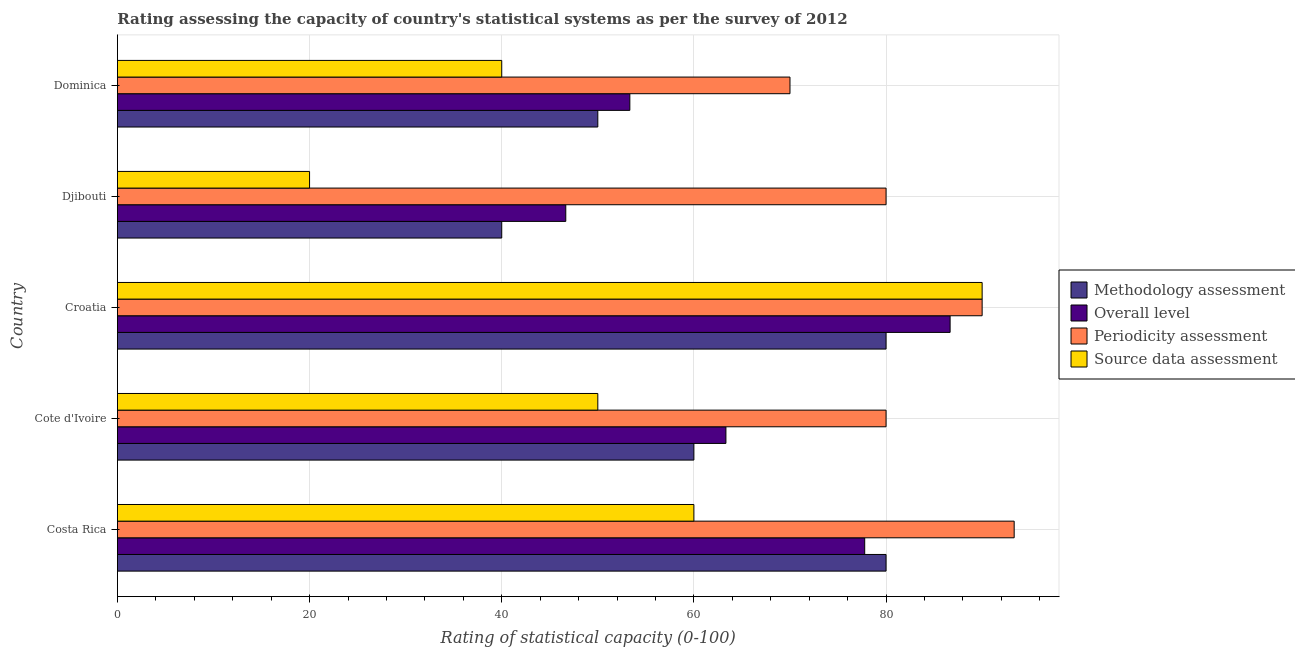How many groups of bars are there?
Your answer should be very brief. 5. Are the number of bars on each tick of the Y-axis equal?
Provide a short and direct response. Yes. What is the label of the 3rd group of bars from the top?
Give a very brief answer. Croatia. In how many cases, is the number of bars for a given country not equal to the number of legend labels?
Make the answer very short. 0. What is the periodicity assessment rating in Djibouti?
Ensure brevity in your answer.  80. Across all countries, what is the maximum source data assessment rating?
Give a very brief answer. 90. In which country was the source data assessment rating maximum?
Offer a terse response. Croatia. In which country was the source data assessment rating minimum?
Provide a short and direct response. Djibouti. What is the total source data assessment rating in the graph?
Keep it short and to the point. 260. What is the difference between the methodology assessment rating in Djibouti and that in Dominica?
Provide a short and direct response. -10. What is the difference between the source data assessment rating in Costa Rica and the overall level rating in Croatia?
Your response must be concise. -26.67. Is the overall level rating in Cote d'Ivoire less than that in Dominica?
Your answer should be very brief. No. What is the difference between the highest and the second highest periodicity assessment rating?
Offer a very short reply. 3.33. In how many countries, is the methodology assessment rating greater than the average methodology assessment rating taken over all countries?
Ensure brevity in your answer.  2. What does the 2nd bar from the top in Cote d'Ivoire represents?
Make the answer very short. Periodicity assessment. What does the 3rd bar from the bottom in Djibouti represents?
Your answer should be compact. Periodicity assessment. Are all the bars in the graph horizontal?
Your answer should be very brief. Yes. What is the difference between two consecutive major ticks on the X-axis?
Your response must be concise. 20. Does the graph contain any zero values?
Provide a succinct answer. No. How are the legend labels stacked?
Your answer should be compact. Vertical. What is the title of the graph?
Provide a succinct answer. Rating assessing the capacity of country's statistical systems as per the survey of 2012 . What is the label or title of the X-axis?
Provide a succinct answer. Rating of statistical capacity (0-100). What is the label or title of the Y-axis?
Offer a very short reply. Country. What is the Rating of statistical capacity (0-100) of Overall level in Costa Rica?
Provide a succinct answer. 77.78. What is the Rating of statistical capacity (0-100) in Periodicity assessment in Costa Rica?
Keep it short and to the point. 93.33. What is the Rating of statistical capacity (0-100) of Methodology assessment in Cote d'Ivoire?
Offer a very short reply. 60. What is the Rating of statistical capacity (0-100) of Overall level in Cote d'Ivoire?
Provide a succinct answer. 63.33. What is the Rating of statistical capacity (0-100) in Periodicity assessment in Cote d'Ivoire?
Offer a very short reply. 80. What is the Rating of statistical capacity (0-100) of Source data assessment in Cote d'Ivoire?
Provide a short and direct response. 50. What is the Rating of statistical capacity (0-100) in Methodology assessment in Croatia?
Provide a short and direct response. 80. What is the Rating of statistical capacity (0-100) in Overall level in Croatia?
Your response must be concise. 86.67. What is the Rating of statistical capacity (0-100) of Overall level in Djibouti?
Your response must be concise. 46.67. What is the Rating of statistical capacity (0-100) of Periodicity assessment in Djibouti?
Ensure brevity in your answer.  80. What is the Rating of statistical capacity (0-100) of Overall level in Dominica?
Provide a succinct answer. 53.33. What is the Rating of statistical capacity (0-100) of Periodicity assessment in Dominica?
Ensure brevity in your answer.  70. Across all countries, what is the maximum Rating of statistical capacity (0-100) in Overall level?
Give a very brief answer. 86.67. Across all countries, what is the maximum Rating of statistical capacity (0-100) in Periodicity assessment?
Give a very brief answer. 93.33. Across all countries, what is the maximum Rating of statistical capacity (0-100) in Source data assessment?
Offer a terse response. 90. Across all countries, what is the minimum Rating of statistical capacity (0-100) in Methodology assessment?
Keep it short and to the point. 40. Across all countries, what is the minimum Rating of statistical capacity (0-100) in Overall level?
Keep it short and to the point. 46.67. Across all countries, what is the minimum Rating of statistical capacity (0-100) in Periodicity assessment?
Keep it short and to the point. 70. Across all countries, what is the minimum Rating of statistical capacity (0-100) in Source data assessment?
Your response must be concise. 20. What is the total Rating of statistical capacity (0-100) in Methodology assessment in the graph?
Provide a short and direct response. 310. What is the total Rating of statistical capacity (0-100) of Overall level in the graph?
Your response must be concise. 327.78. What is the total Rating of statistical capacity (0-100) of Periodicity assessment in the graph?
Ensure brevity in your answer.  413.33. What is the total Rating of statistical capacity (0-100) of Source data assessment in the graph?
Provide a short and direct response. 260. What is the difference between the Rating of statistical capacity (0-100) in Overall level in Costa Rica and that in Cote d'Ivoire?
Keep it short and to the point. 14.44. What is the difference between the Rating of statistical capacity (0-100) in Periodicity assessment in Costa Rica and that in Cote d'Ivoire?
Offer a very short reply. 13.33. What is the difference between the Rating of statistical capacity (0-100) of Source data assessment in Costa Rica and that in Cote d'Ivoire?
Your answer should be very brief. 10. What is the difference between the Rating of statistical capacity (0-100) in Overall level in Costa Rica and that in Croatia?
Keep it short and to the point. -8.89. What is the difference between the Rating of statistical capacity (0-100) of Source data assessment in Costa Rica and that in Croatia?
Ensure brevity in your answer.  -30. What is the difference between the Rating of statistical capacity (0-100) of Overall level in Costa Rica and that in Djibouti?
Provide a succinct answer. 31.11. What is the difference between the Rating of statistical capacity (0-100) in Periodicity assessment in Costa Rica and that in Djibouti?
Provide a short and direct response. 13.33. What is the difference between the Rating of statistical capacity (0-100) in Source data assessment in Costa Rica and that in Djibouti?
Make the answer very short. 40. What is the difference between the Rating of statistical capacity (0-100) of Methodology assessment in Costa Rica and that in Dominica?
Keep it short and to the point. 30. What is the difference between the Rating of statistical capacity (0-100) in Overall level in Costa Rica and that in Dominica?
Make the answer very short. 24.44. What is the difference between the Rating of statistical capacity (0-100) of Periodicity assessment in Costa Rica and that in Dominica?
Keep it short and to the point. 23.33. What is the difference between the Rating of statistical capacity (0-100) in Methodology assessment in Cote d'Ivoire and that in Croatia?
Offer a very short reply. -20. What is the difference between the Rating of statistical capacity (0-100) in Overall level in Cote d'Ivoire and that in Croatia?
Make the answer very short. -23.33. What is the difference between the Rating of statistical capacity (0-100) of Periodicity assessment in Cote d'Ivoire and that in Croatia?
Provide a succinct answer. -10. What is the difference between the Rating of statistical capacity (0-100) of Source data assessment in Cote d'Ivoire and that in Croatia?
Make the answer very short. -40. What is the difference between the Rating of statistical capacity (0-100) of Overall level in Cote d'Ivoire and that in Djibouti?
Give a very brief answer. 16.67. What is the difference between the Rating of statistical capacity (0-100) in Periodicity assessment in Cote d'Ivoire and that in Djibouti?
Provide a succinct answer. 0. What is the difference between the Rating of statistical capacity (0-100) in Methodology assessment in Cote d'Ivoire and that in Dominica?
Offer a terse response. 10. What is the difference between the Rating of statistical capacity (0-100) in Periodicity assessment in Cote d'Ivoire and that in Dominica?
Offer a very short reply. 10. What is the difference between the Rating of statistical capacity (0-100) in Periodicity assessment in Croatia and that in Djibouti?
Keep it short and to the point. 10. What is the difference between the Rating of statistical capacity (0-100) of Source data assessment in Croatia and that in Djibouti?
Keep it short and to the point. 70. What is the difference between the Rating of statistical capacity (0-100) of Methodology assessment in Croatia and that in Dominica?
Ensure brevity in your answer.  30. What is the difference between the Rating of statistical capacity (0-100) of Overall level in Croatia and that in Dominica?
Offer a very short reply. 33.33. What is the difference between the Rating of statistical capacity (0-100) of Overall level in Djibouti and that in Dominica?
Offer a very short reply. -6.67. What is the difference between the Rating of statistical capacity (0-100) in Methodology assessment in Costa Rica and the Rating of statistical capacity (0-100) in Overall level in Cote d'Ivoire?
Make the answer very short. 16.67. What is the difference between the Rating of statistical capacity (0-100) in Methodology assessment in Costa Rica and the Rating of statistical capacity (0-100) in Periodicity assessment in Cote d'Ivoire?
Provide a short and direct response. 0. What is the difference between the Rating of statistical capacity (0-100) in Methodology assessment in Costa Rica and the Rating of statistical capacity (0-100) in Source data assessment in Cote d'Ivoire?
Your response must be concise. 30. What is the difference between the Rating of statistical capacity (0-100) in Overall level in Costa Rica and the Rating of statistical capacity (0-100) in Periodicity assessment in Cote d'Ivoire?
Give a very brief answer. -2.22. What is the difference between the Rating of statistical capacity (0-100) of Overall level in Costa Rica and the Rating of statistical capacity (0-100) of Source data assessment in Cote d'Ivoire?
Give a very brief answer. 27.78. What is the difference between the Rating of statistical capacity (0-100) in Periodicity assessment in Costa Rica and the Rating of statistical capacity (0-100) in Source data assessment in Cote d'Ivoire?
Offer a very short reply. 43.33. What is the difference between the Rating of statistical capacity (0-100) of Methodology assessment in Costa Rica and the Rating of statistical capacity (0-100) of Overall level in Croatia?
Ensure brevity in your answer.  -6.67. What is the difference between the Rating of statistical capacity (0-100) of Methodology assessment in Costa Rica and the Rating of statistical capacity (0-100) of Source data assessment in Croatia?
Your answer should be very brief. -10. What is the difference between the Rating of statistical capacity (0-100) of Overall level in Costa Rica and the Rating of statistical capacity (0-100) of Periodicity assessment in Croatia?
Offer a very short reply. -12.22. What is the difference between the Rating of statistical capacity (0-100) in Overall level in Costa Rica and the Rating of statistical capacity (0-100) in Source data assessment in Croatia?
Your answer should be very brief. -12.22. What is the difference between the Rating of statistical capacity (0-100) in Periodicity assessment in Costa Rica and the Rating of statistical capacity (0-100) in Source data assessment in Croatia?
Your answer should be very brief. 3.33. What is the difference between the Rating of statistical capacity (0-100) in Methodology assessment in Costa Rica and the Rating of statistical capacity (0-100) in Overall level in Djibouti?
Ensure brevity in your answer.  33.33. What is the difference between the Rating of statistical capacity (0-100) in Methodology assessment in Costa Rica and the Rating of statistical capacity (0-100) in Source data assessment in Djibouti?
Your response must be concise. 60. What is the difference between the Rating of statistical capacity (0-100) in Overall level in Costa Rica and the Rating of statistical capacity (0-100) in Periodicity assessment in Djibouti?
Your response must be concise. -2.22. What is the difference between the Rating of statistical capacity (0-100) of Overall level in Costa Rica and the Rating of statistical capacity (0-100) of Source data assessment in Djibouti?
Your answer should be very brief. 57.78. What is the difference between the Rating of statistical capacity (0-100) of Periodicity assessment in Costa Rica and the Rating of statistical capacity (0-100) of Source data assessment in Djibouti?
Provide a short and direct response. 73.33. What is the difference between the Rating of statistical capacity (0-100) in Methodology assessment in Costa Rica and the Rating of statistical capacity (0-100) in Overall level in Dominica?
Make the answer very short. 26.67. What is the difference between the Rating of statistical capacity (0-100) in Methodology assessment in Costa Rica and the Rating of statistical capacity (0-100) in Source data assessment in Dominica?
Provide a succinct answer. 40. What is the difference between the Rating of statistical capacity (0-100) of Overall level in Costa Rica and the Rating of statistical capacity (0-100) of Periodicity assessment in Dominica?
Give a very brief answer. 7.78. What is the difference between the Rating of statistical capacity (0-100) in Overall level in Costa Rica and the Rating of statistical capacity (0-100) in Source data assessment in Dominica?
Offer a terse response. 37.78. What is the difference between the Rating of statistical capacity (0-100) in Periodicity assessment in Costa Rica and the Rating of statistical capacity (0-100) in Source data assessment in Dominica?
Give a very brief answer. 53.33. What is the difference between the Rating of statistical capacity (0-100) of Methodology assessment in Cote d'Ivoire and the Rating of statistical capacity (0-100) of Overall level in Croatia?
Your answer should be compact. -26.67. What is the difference between the Rating of statistical capacity (0-100) of Methodology assessment in Cote d'Ivoire and the Rating of statistical capacity (0-100) of Source data assessment in Croatia?
Your response must be concise. -30. What is the difference between the Rating of statistical capacity (0-100) in Overall level in Cote d'Ivoire and the Rating of statistical capacity (0-100) in Periodicity assessment in Croatia?
Your answer should be very brief. -26.67. What is the difference between the Rating of statistical capacity (0-100) in Overall level in Cote d'Ivoire and the Rating of statistical capacity (0-100) in Source data assessment in Croatia?
Give a very brief answer. -26.67. What is the difference between the Rating of statistical capacity (0-100) of Methodology assessment in Cote d'Ivoire and the Rating of statistical capacity (0-100) of Overall level in Djibouti?
Give a very brief answer. 13.33. What is the difference between the Rating of statistical capacity (0-100) of Methodology assessment in Cote d'Ivoire and the Rating of statistical capacity (0-100) of Periodicity assessment in Djibouti?
Your response must be concise. -20. What is the difference between the Rating of statistical capacity (0-100) of Overall level in Cote d'Ivoire and the Rating of statistical capacity (0-100) of Periodicity assessment in Djibouti?
Your answer should be compact. -16.67. What is the difference between the Rating of statistical capacity (0-100) of Overall level in Cote d'Ivoire and the Rating of statistical capacity (0-100) of Source data assessment in Djibouti?
Offer a very short reply. 43.33. What is the difference between the Rating of statistical capacity (0-100) in Periodicity assessment in Cote d'Ivoire and the Rating of statistical capacity (0-100) in Source data assessment in Djibouti?
Provide a short and direct response. 60. What is the difference between the Rating of statistical capacity (0-100) of Methodology assessment in Cote d'Ivoire and the Rating of statistical capacity (0-100) of Source data assessment in Dominica?
Make the answer very short. 20. What is the difference between the Rating of statistical capacity (0-100) of Overall level in Cote d'Ivoire and the Rating of statistical capacity (0-100) of Periodicity assessment in Dominica?
Ensure brevity in your answer.  -6.67. What is the difference between the Rating of statistical capacity (0-100) in Overall level in Cote d'Ivoire and the Rating of statistical capacity (0-100) in Source data assessment in Dominica?
Ensure brevity in your answer.  23.33. What is the difference between the Rating of statistical capacity (0-100) of Methodology assessment in Croatia and the Rating of statistical capacity (0-100) of Overall level in Djibouti?
Your answer should be very brief. 33.33. What is the difference between the Rating of statistical capacity (0-100) of Methodology assessment in Croatia and the Rating of statistical capacity (0-100) of Periodicity assessment in Djibouti?
Offer a very short reply. 0. What is the difference between the Rating of statistical capacity (0-100) of Overall level in Croatia and the Rating of statistical capacity (0-100) of Source data assessment in Djibouti?
Provide a succinct answer. 66.67. What is the difference between the Rating of statistical capacity (0-100) in Periodicity assessment in Croatia and the Rating of statistical capacity (0-100) in Source data assessment in Djibouti?
Provide a succinct answer. 70. What is the difference between the Rating of statistical capacity (0-100) of Methodology assessment in Croatia and the Rating of statistical capacity (0-100) of Overall level in Dominica?
Offer a very short reply. 26.67. What is the difference between the Rating of statistical capacity (0-100) in Methodology assessment in Croatia and the Rating of statistical capacity (0-100) in Periodicity assessment in Dominica?
Provide a short and direct response. 10. What is the difference between the Rating of statistical capacity (0-100) of Methodology assessment in Croatia and the Rating of statistical capacity (0-100) of Source data assessment in Dominica?
Give a very brief answer. 40. What is the difference between the Rating of statistical capacity (0-100) in Overall level in Croatia and the Rating of statistical capacity (0-100) in Periodicity assessment in Dominica?
Your answer should be compact. 16.67. What is the difference between the Rating of statistical capacity (0-100) of Overall level in Croatia and the Rating of statistical capacity (0-100) of Source data assessment in Dominica?
Your answer should be very brief. 46.67. What is the difference between the Rating of statistical capacity (0-100) of Periodicity assessment in Croatia and the Rating of statistical capacity (0-100) of Source data assessment in Dominica?
Offer a very short reply. 50. What is the difference between the Rating of statistical capacity (0-100) in Methodology assessment in Djibouti and the Rating of statistical capacity (0-100) in Overall level in Dominica?
Provide a succinct answer. -13.33. What is the difference between the Rating of statistical capacity (0-100) in Methodology assessment in Djibouti and the Rating of statistical capacity (0-100) in Periodicity assessment in Dominica?
Provide a short and direct response. -30. What is the difference between the Rating of statistical capacity (0-100) of Overall level in Djibouti and the Rating of statistical capacity (0-100) of Periodicity assessment in Dominica?
Offer a very short reply. -23.33. What is the difference between the Rating of statistical capacity (0-100) in Periodicity assessment in Djibouti and the Rating of statistical capacity (0-100) in Source data assessment in Dominica?
Give a very brief answer. 40. What is the average Rating of statistical capacity (0-100) in Methodology assessment per country?
Your response must be concise. 62. What is the average Rating of statistical capacity (0-100) in Overall level per country?
Your answer should be compact. 65.56. What is the average Rating of statistical capacity (0-100) in Periodicity assessment per country?
Offer a very short reply. 82.67. What is the average Rating of statistical capacity (0-100) in Source data assessment per country?
Give a very brief answer. 52. What is the difference between the Rating of statistical capacity (0-100) of Methodology assessment and Rating of statistical capacity (0-100) of Overall level in Costa Rica?
Provide a short and direct response. 2.22. What is the difference between the Rating of statistical capacity (0-100) of Methodology assessment and Rating of statistical capacity (0-100) of Periodicity assessment in Costa Rica?
Ensure brevity in your answer.  -13.33. What is the difference between the Rating of statistical capacity (0-100) of Overall level and Rating of statistical capacity (0-100) of Periodicity assessment in Costa Rica?
Your response must be concise. -15.56. What is the difference between the Rating of statistical capacity (0-100) of Overall level and Rating of statistical capacity (0-100) of Source data assessment in Costa Rica?
Ensure brevity in your answer.  17.78. What is the difference between the Rating of statistical capacity (0-100) of Periodicity assessment and Rating of statistical capacity (0-100) of Source data assessment in Costa Rica?
Provide a short and direct response. 33.33. What is the difference between the Rating of statistical capacity (0-100) in Methodology assessment and Rating of statistical capacity (0-100) in Overall level in Cote d'Ivoire?
Your answer should be very brief. -3.33. What is the difference between the Rating of statistical capacity (0-100) of Methodology assessment and Rating of statistical capacity (0-100) of Source data assessment in Cote d'Ivoire?
Give a very brief answer. 10. What is the difference between the Rating of statistical capacity (0-100) of Overall level and Rating of statistical capacity (0-100) of Periodicity assessment in Cote d'Ivoire?
Your answer should be compact. -16.67. What is the difference between the Rating of statistical capacity (0-100) of Overall level and Rating of statistical capacity (0-100) of Source data assessment in Cote d'Ivoire?
Provide a succinct answer. 13.33. What is the difference between the Rating of statistical capacity (0-100) of Periodicity assessment and Rating of statistical capacity (0-100) of Source data assessment in Cote d'Ivoire?
Make the answer very short. 30. What is the difference between the Rating of statistical capacity (0-100) of Methodology assessment and Rating of statistical capacity (0-100) of Overall level in Croatia?
Ensure brevity in your answer.  -6.67. What is the difference between the Rating of statistical capacity (0-100) in Methodology assessment and Rating of statistical capacity (0-100) in Periodicity assessment in Croatia?
Make the answer very short. -10. What is the difference between the Rating of statistical capacity (0-100) of Methodology assessment and Rating of statistical capacity (0-100) of Source data assessment in Croatia?
Ensure brevity in your answer.  -10. What is the difference between the Rating of statistical capacity (0-100) in Overall level and Rating of statistical capacity (0-100) in Periodicity assessment in Croatia?
Offer a terse response. -3.33. What is the difference between the Rating of statistical capacity (0-100) of Methodology assessment and Rating of statistical capacity (0-100) of Overall level in Djibouti?
Your answer should be compact. -6.67. What is the difference between the Rating of statistical capacity (0-100) in Methodology assessment and Rating of statistical capacity (0-100) in Periodicity assessment in Djibouti?
Your answer should be compact. -40. What is the difference between the Rating of statistical capacity (0-100) in Methodology assessment and Rating of statistical capacity (0-100) in Source data assessment in Djibouti?
Ensure brevity in your answer.  20. What is the difference between the Rating of statistical capacity (0-100) in Overall level and Rating of statistical capacity (0-100) in Periodicity assessment in Djibouti?
Give a very brief answer. -33.33. What is the difference between the Rating of statistical capacity (0-100) of Overall level and Rating of statistical capacity (0-100) of Source data assessment in Djibouti?
Make the answer very short. 26.67. What is the difference between the Rating of statistical capacity (0-100) in Periodicity assessment and Rating of statistical capacity (0-100) in Source data assessment in Djibouti?
Provide a succinct answer. 60. What is the difference between the Rating of statistical capacity (0-100) of Methodology assessment and Rating of statistical capacity (0-100) of Periodicity assessment in Dominica?
Your answer should be compact. -20. What is the difference between the Rating of statistical capacity (0-100) in Methodology assessment and Rating of statistical capacity (0-100) in Source data assessment in Dominica?
Your answer should be compact. 10. What is the difference between the Rating of statistical capacity (0-100) of Overall level and Rating of statistical capacity (0-100) of Periodicity assessment in Dominica?
Your response must be concise. -16.67. What is the difference between the Rating of statistical capacity (0-100) of Overall level and Rating of statistical capacity (0-100) of Source data assessment in Dominica?
Keep it short and to the point. 13.33. What is the difference between the Rating of statistical capacity (0-100) in Periodicity assessment and Rating of statistical capacity (0-100) in Source data assessment in Dominica?
Provide a succinct answer. 30. What is the ratio of the Rating of statistical capacity (0-100) in Overall level in Costa Rica to that in Cote d'Ivoire?
Keep it short and to the point. 1.23. What is the ratio of the Rating of statistical capacity (0-100) of Periodicity assessment in Costa Rica to that in Cote d'Ivoire?
Keep it short and to the point. 1.17. What is the ratio of the Rating of statistical capacity (0-100) in Overall level in Costa Rica to that in Croatia?
Offer a very short reply. 0.9. What is the ratio of the Rating of statistical capacity (0-100) in Source data assessment in Costa Rica to that in Croatia?
Offer a terse response. 0.67. What is the ratio of the Rating of statistical capacity (0-100) in Overall level in Costa Rica to that in Djibouti?
Offer a very short reply. 1.67. What is the ratio of the Rating of statistical capacity (0-100) in Overall level in Costa Rica to that in Dominica?
Give a very brief answer. 1.46. What is the ratio of the Rating of statistical capacity (0-100) of Source data assessment in Costa Rica to that in Dominica?
Your response must be concise. 1.5. What is the ratio of the Rating of statistical capacity (0-100) in Methodology assessment in Cote d'Ivoire to that in Croatia?
Make the answer very short. 0.75. What is the ratio of the Rating of statistical capacity (0-100) of Overall level in Cote d'Ivoire to that in Croatia?
Make the answer very short. 0.73. What is the ratio of the Rating of statistical capacity (0-100) in Periodicity assessment in Cote d'Ivoire to that in Croatia?
Keep it short and to the point. 0.89. What is the ratio of the Rating of statistical capacity (0-100) in Source data assessment in Cote d'Ivoire to that in Croatia?
Give a very brief answer. 0.56. What is the ratio of the Rating of statistical capacity (0-100) in Methodology assessment in Cote d'Ivoire to that in Djibouti?
Offer a very short reply. 1.5. What is the ratio of the Rating of statistical capacity (0-100) of Overall level in Cote d'Ivoire to that in Djibouti?
Your response must be concise. 1.36. What is the ratio of the Rating of statistical capacity (0-100) in Overall level in Cote d'Ivoire to that in Dominica?
Keep it short and to the point. 1.19. What is the ratio of the Rating of statistical capacity (0-100) in Overall level in Croatia to that in Djibouti?
Ensure brevity in your answer.  1.86. What is the ratio of the Rating of statistical capacity (0-100) of Periodicity assessment in Croatia to that in Djibouti?
Your response must be concise. 1.12. What is the ratio of the Rating of statistical capacity (0-100) of Source data assessment in Croatia to that in Djibouti?
Your response must be concise. 4.5. What is the ratio of the Rating of statistical capacity (0-100) in Methodology assessment in Croatia to that in Dominica?
Provide a short and direct response. 1.6. What is the ratio of the Rating of statistical capacity (0-100) in Overall level in Croatia to that in Dominica?
Your answer should be compact. 1.62. What is the ratio of the Rating of statistical capacity (0-100) of Periodicity assessment in Croatia to that in Dominica?
Provide a short and direct response. 1.29. What is the ratio of the Rating of statistical capacity (0-100) of Source data assessment in Croatia to that in Dominica?
Keep it short and to the point. 2.25. What is the ratio of the Rating of statistical capacity (0-100) in Methodology assessment in Djibouti to that in Dominica?
Offer a terse response. 0.8. What is the ratio of the Rating of statistical capacity (0-100) in Periodicity assessment in Djibouti to that in Dominica?
Offer a terse response. 1.14. What is the ratio of the Rating of statistical capacity (0-100) of Source data assessment in Djibouti to that in Dominica?
Your answer should be compact. 0.5. What is the difference between the highest and the second highest Rating of statistical capacity (0-100) of Overall level?
Provide a short and direct response. 8.89. What is the difference between the highest and the second highest Rating of statistical capacity (0-100) of Periodicity assessment?
Offer a terse response. 3.33. What is the difference between the highest and the lowest Rating of statistical capacity (0-100) of Methodology assessment?
Ensure brevity in your answer.  40. What is the difference between the highest and the lowest Rating of statistical capacity (0-100) in Overall level?
Give a very brief answer. 40. What is the difference between the highest and the lowest Rating of statistical capacity (0-100) in Periodicity assessment?
Make the answer very short. 23.33. What is the difference between the highest and the lowest Rating of statistical capacity (0-100) in Source data assessment?
Give a very brief answer. 70. 